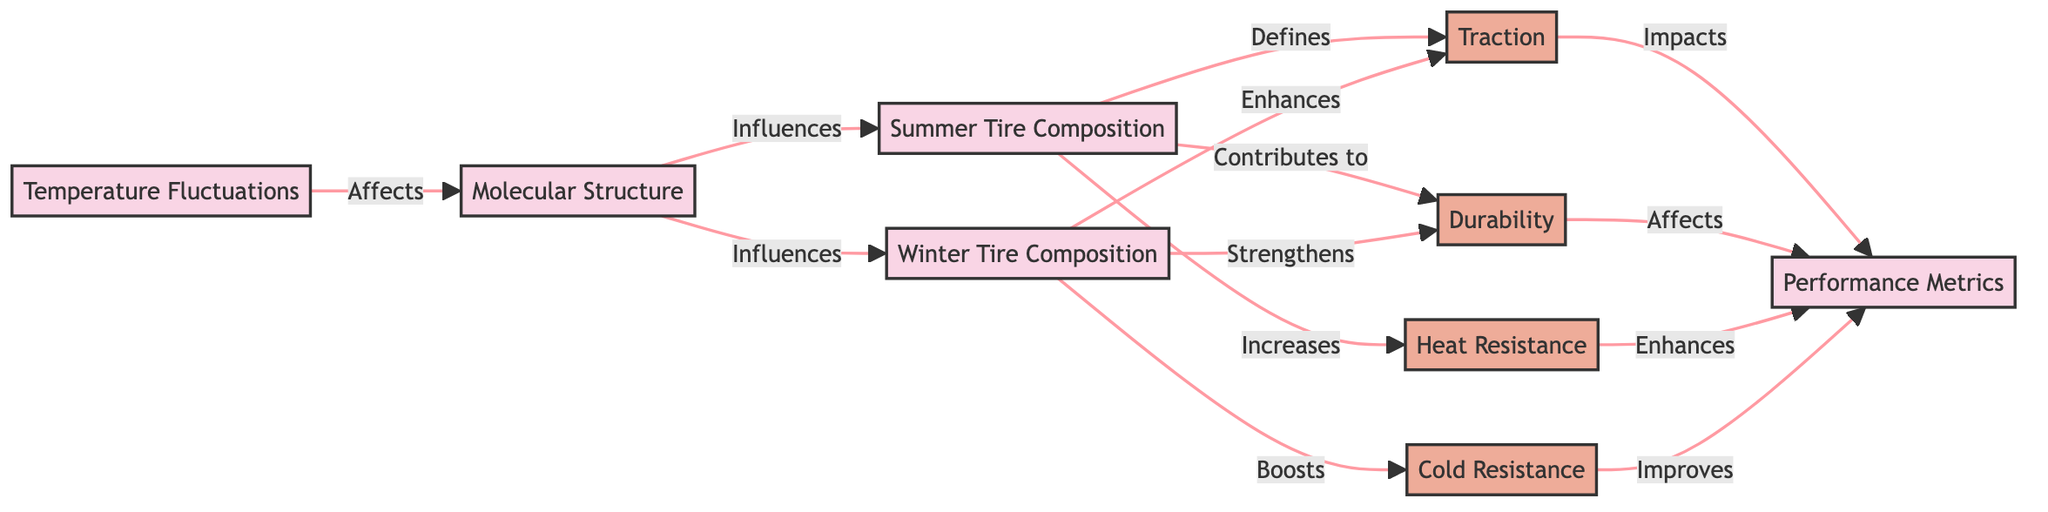What is affected by Temperature Fluctuations? According to the diagram, Temperature Fluctuations directly affects Molecular Structure, as indicated by the arrow pointing from Temperature Fluctuations to Molecular Structure.
Answer: Molecular Structure How many performance metrics are listed in the diagram? The diagram shows four performance metrics: Traction, Durability, Heat Resistance, and Cold Resistance. These are represented as attributes connected to Performance Metrics.
Answer: Four Which tire composition enhances Traction more? The diagram indicates that Winter Tire Composition enhances Traction, while Summer Tire Composition defines Traction. Since "enhances" indicates a stronger contribution than "defines," Winter tires improve Traction more.
Answer: Winter Tire Composition What is the relationship between Molecular Structure and Summer Tire Composition? The diagram shows that Molecular Structure influences Summer Tire Composition, indicating that changes in the molecular structure result in variations in the composition of summer tires.
Answer: Influences Which performance metric is improved by Cold Resistance? The diagram illustrates that Cold Resistance improves the Performance Metrics, linking it directly to the Performance Metrics node.
Answer: Performance Metrics 